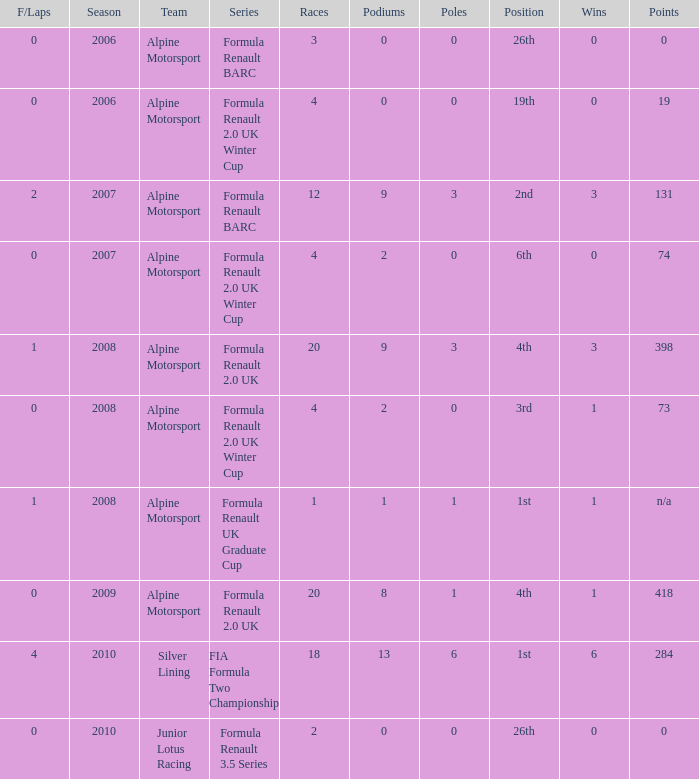What races achieved 0 f/laps and 1 pole position? 20.0. 